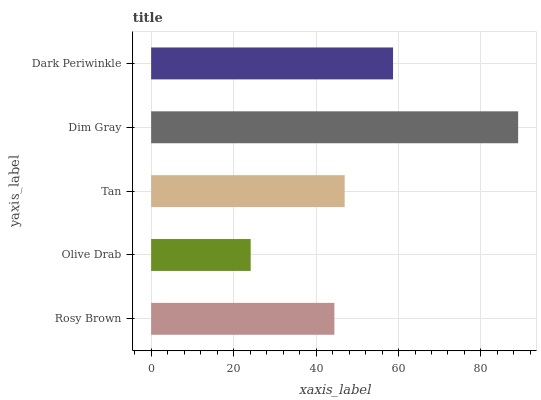Is Olive Drab the minimum?
Answer yes or no. Yes. Is Dim Gray the maximum?
Answer yes or no. Yes. Is Tan the minimum?
Answer yes or no. No. Is Tan the maximum?
Answer yes or no. No. Is Tan greater than Olive Drab?
Answer yes or no. Yes. Is Olive Drab less than Tan?
Answer yes or no. Yes. Is Olive Drab greater than Tan?
Answer yes or no. No. Is Tan less than Olive Drab?
Answer yes or no. No. Is Tan the high median?
Answer yes or no. Yes. Is Tan the low median?
Answer yes or no. Yes. Is Olive Drab the high median?
Answer yes or no. No. Is Olive Drab the low median?
Answer yes or no. No. 